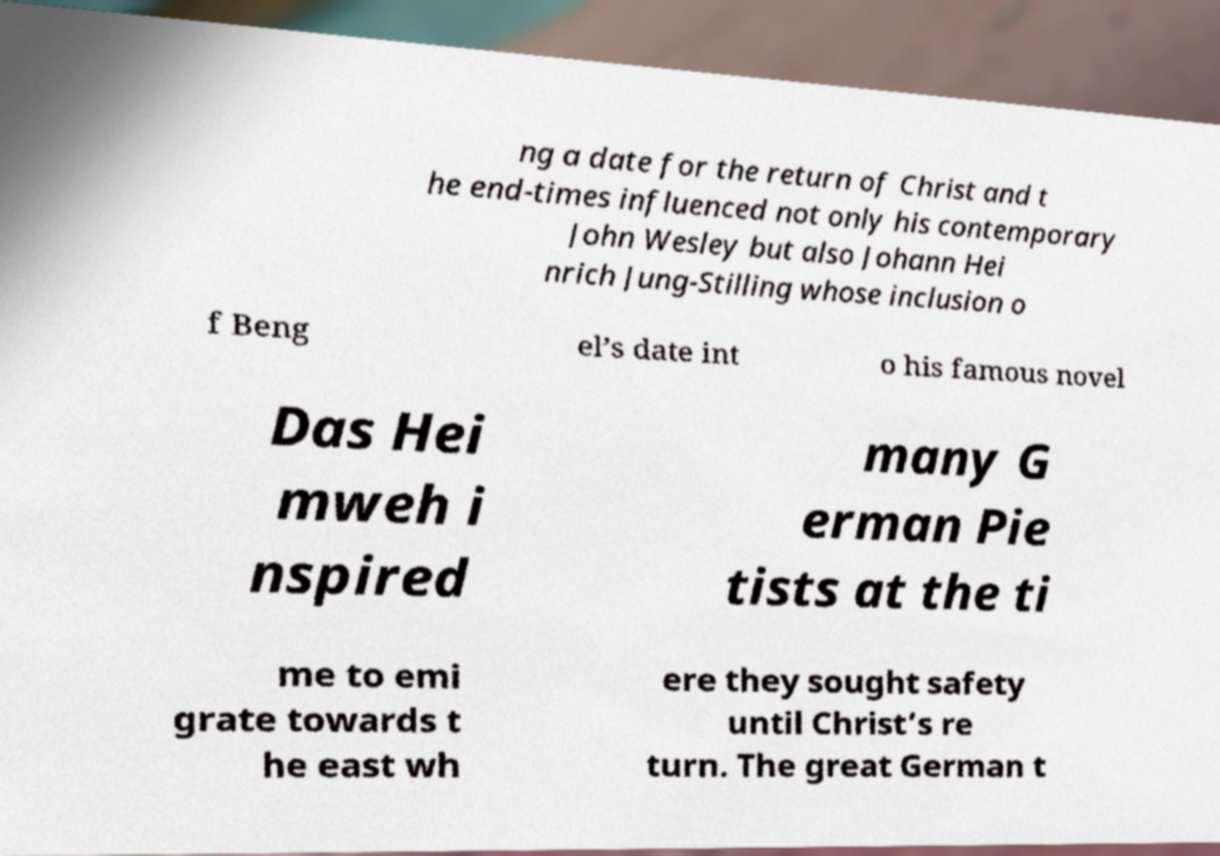Please identify and transcribe the text found in this image. ng a date for the return of Christ and t he end-times influenced not only his contemporary John Wesley but also Johann Hei nrich Jung-Stilling whose inclusion o f Beng el’s date int o his famous novel Das Hei mweh i nspired many G erman Pie tists at the ti me to emi grate towards t he east wh ere they sought safety until Christ’s re turn. The great German t 